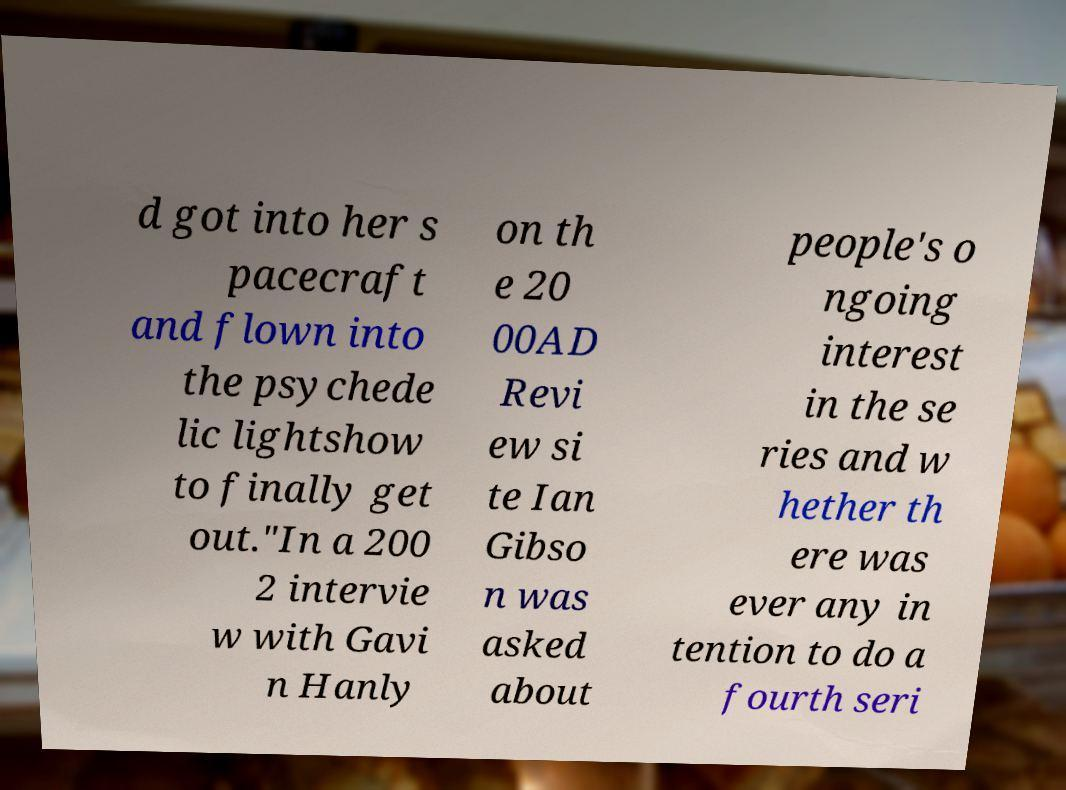Could you extract and type out the text from this image? d got into her s pacecraft and flown into the psychede lic lightshow to finally get out."In a 200 2 intervie w with Gavi n Hanly on th e 20 00AD Revi ew si te Ian Gibso n was asked about people's o ngoing interest in the se ries and w hether th ere was ever any in tention to do a fourth seri 